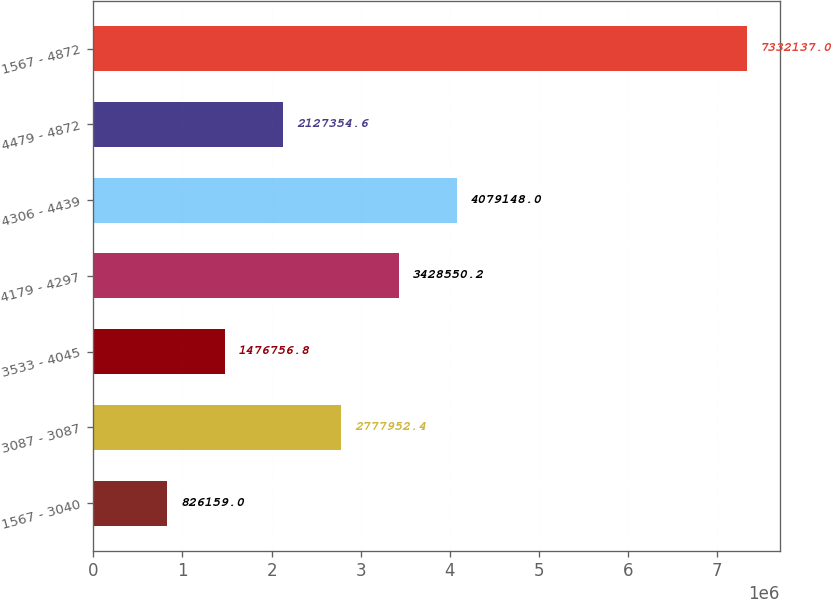<chart> <loc_0><loc_0><loc_500><loc_500><bar_chart><fcel>1567 - 3040<fcel>3087 - 3087<fcel>3533 - 4045<fcel>4179 - 4297<fcel>4306 - 4439<fcel>4479 - 4872<fcel>1567 - 4872<nl><fcel>826159<fcel>2.77795e+06<fcel>1.47676e+06<fcel>3.42855e+06<fcel>4.07915e+06<fcel>2.12735e+06<fcel>7.33214e+06<nl></chart> 